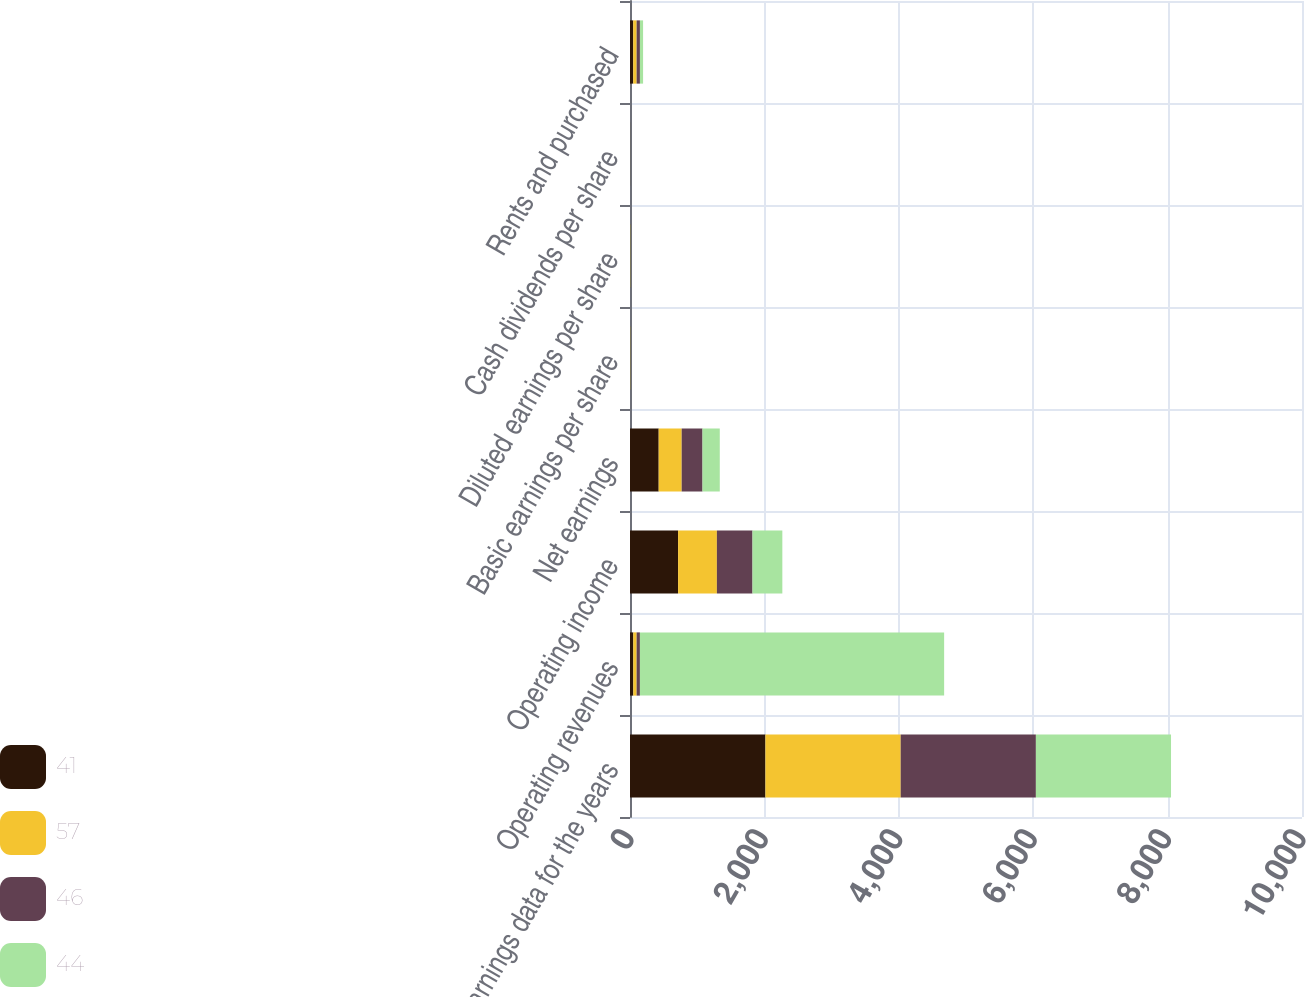Convert chart. <chart><loc_0><loc_0><loc_500><loc_500><stacked_bar_chart><ecel><fcel>Earnings data for the years<fcel>Operating revenues<fcel>Operating income<fcel>Net earnings<fcel>Basic earnings per share<fcel>Diluted earnings per share<fcel>Cash dividends per share<fcel>Rents and purchased<nl><fcel>41<fcel>2015<fcel>49.2<fcel>716<fcel>427<fcel>3.69<fcel>3.66<fcel>0.84<fcel>48.4<nl><fcel>57<fcel>2013<fcel>49.2<fcel>577<fcel>342<fcel>2.92<fcel>2.87<fcel>0.45<fcel>50.2<nl><fcel>46<fcel>2012<fcel>49.2<fcel>530<fcel>310<fcel>2.64<fcel>2.59<fcel>0.71<fcel>49.2<nl><fcel>44<fcel>2011<fcel>4527<fcel>444<fcel>257<fcel>2.16<fcel>2.11<fcel>0.52<fcel>46.9<nl></chart> 